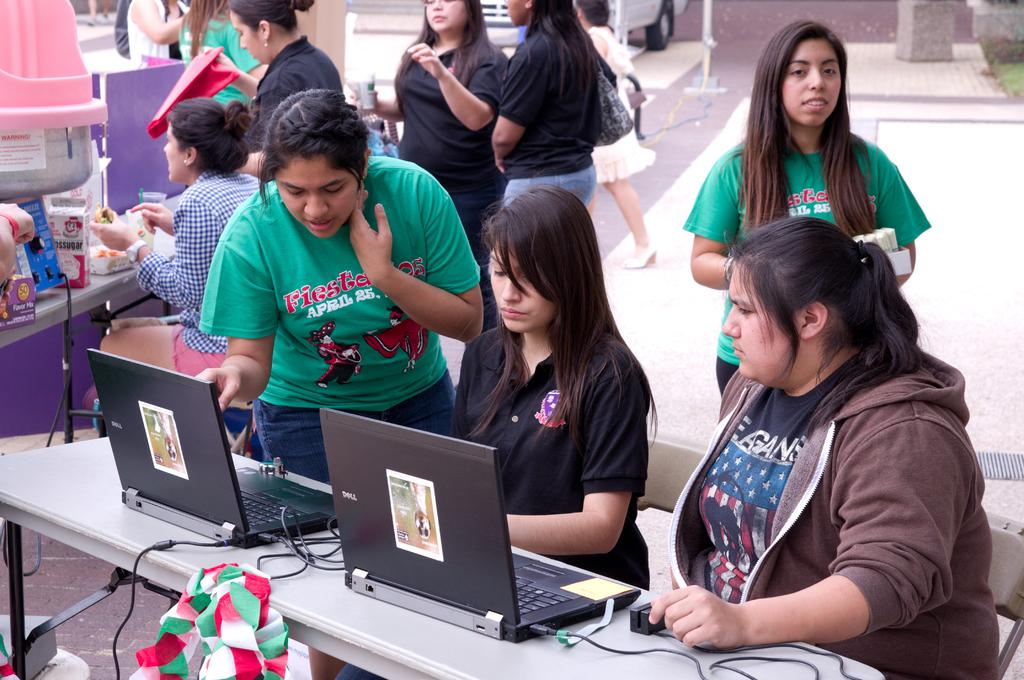Provide a one-sentence caption for the provided image. Several young females working on black DELL laptops. 